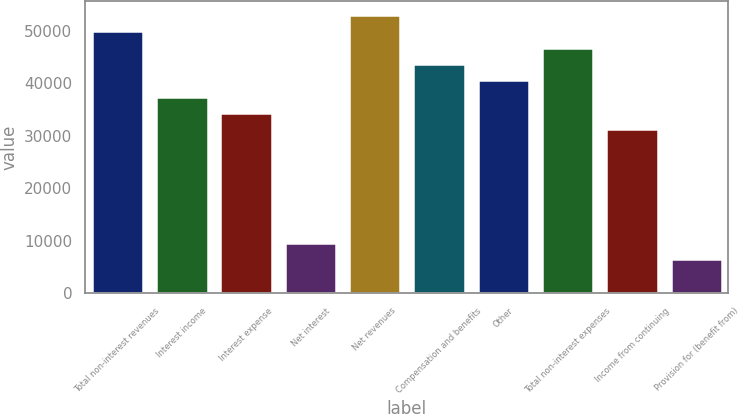Convert chart to OTSL. <chart><loc_0><loc_0><loc_500><loc_500><bar_chart><fcel>Total non-interest revenues<fcel>Interest income<fcel>Interest expense<fcel>Net interest<fcel>Net revenues<fcel>Compensation and benefits<fcel>Other<fcel>Total non-interest expenses<fcel>Income from continuing<fcel>Provision for (benefit from)<nl><fcel>49938.8<fcel>37513.6<fcel>34407.3<fcel>9556.9<fcel>53045.1<fcel>43726.2<fcel>40619.9<fcel>46832.5<fcel>31301<fcel>6450.6<nl></chart> 